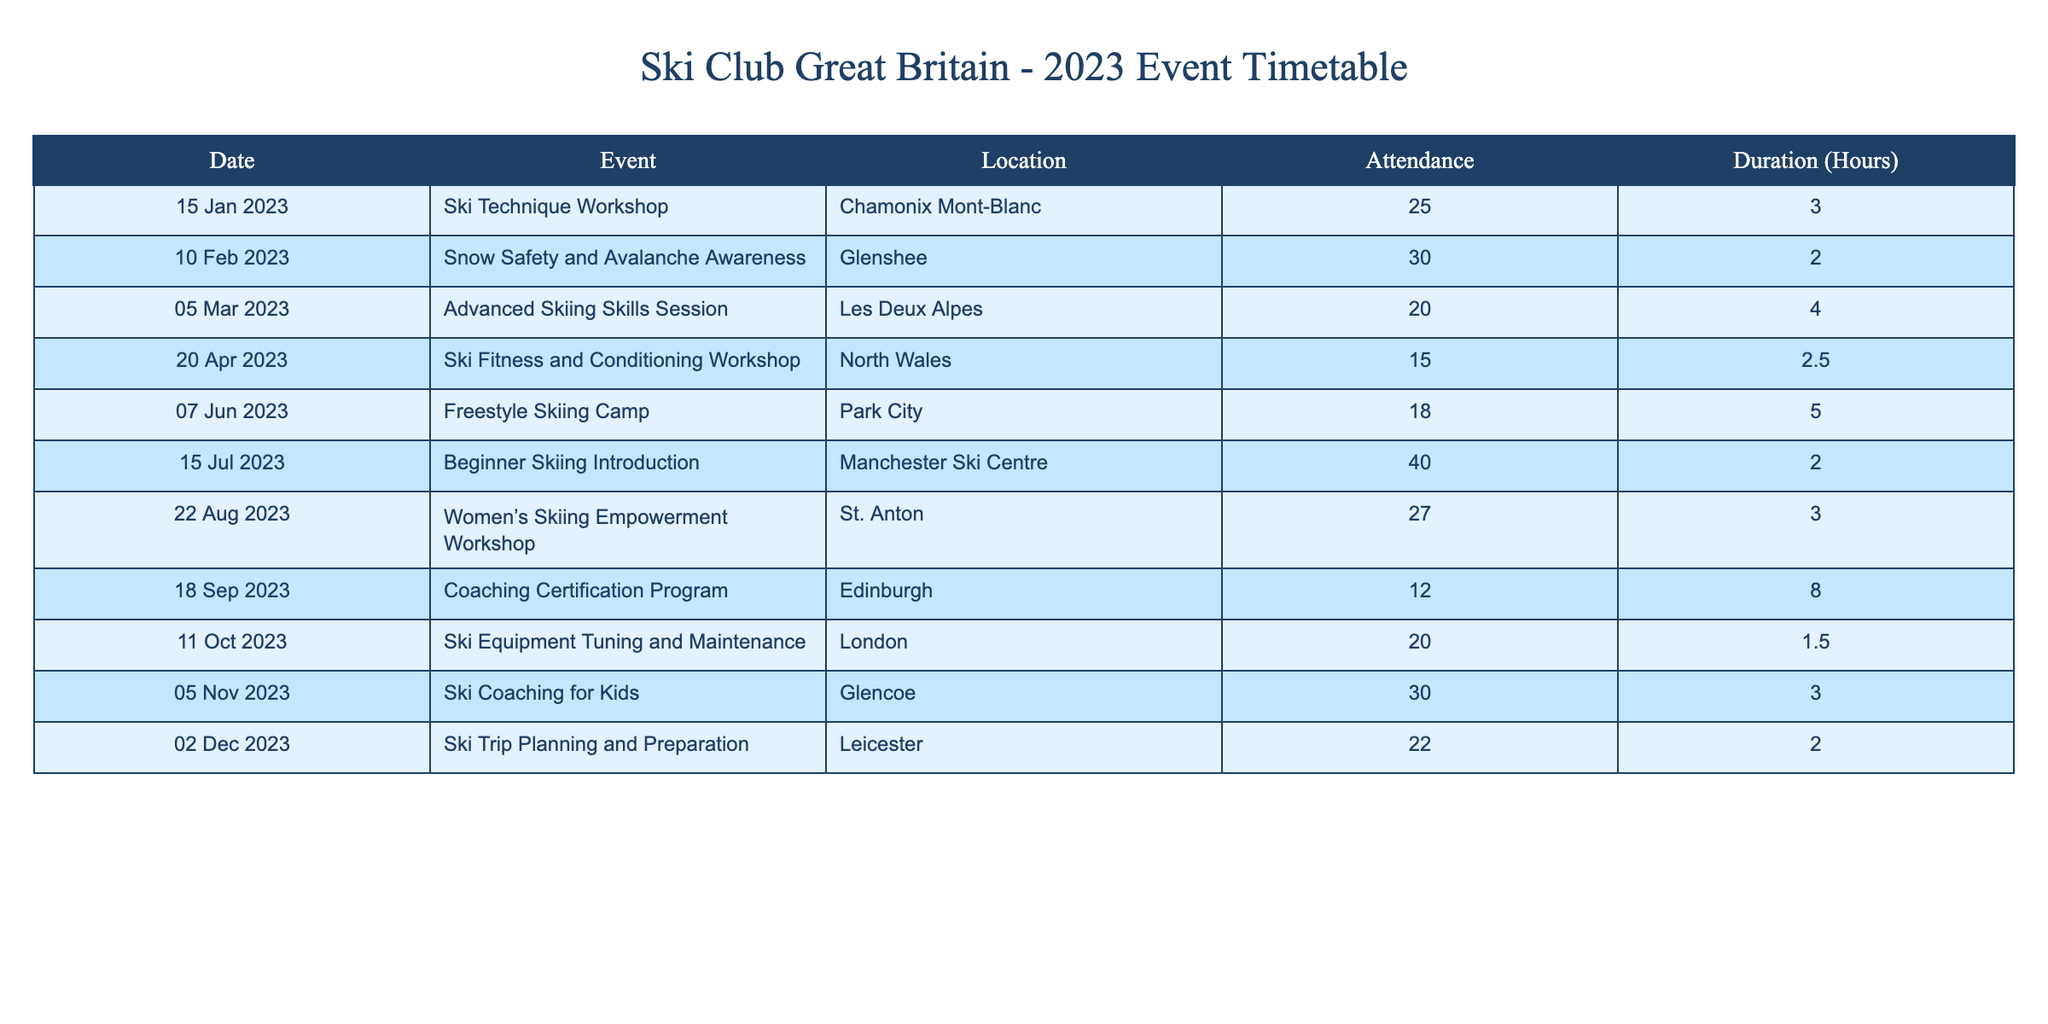What is the highest attendance recorded for a workshop in 2023? The attendance numbers from the table show that the "Beginner Skiing Introduction" event held on July 15 had the highest attendance with 40 participants.
Answer: 40 Which event had the longest duration in hours? By reviewing the duration column, the "Coaching Certification Program" held on September 18 had the longest duration of 8 hours.
Answer: 8 hours What was the average attendance for Ski Club Great Britain events in 2023? To find the average attendance, sum all attendance figures: (25 + 30 + 20 + 15 + 18 + 40 + 27 + 12 + 20 + 30 + 22) =  309. In total, there are 11 events, so the average is 309/11 = 28.09, rounding down gives approximately 28.
Answer: 28 Did more people attend the workshops in Chamonix Mont-Blanc or North Wales? In Chamonix Mont-Blanc, the "Ski Technique Workshop" had 25 attendees, while the workshop in North Wales had 15 attendees for the "Ski Fitness and Conditioning Workshop." Since 25 is greater than 15, more people attended the workshop in Chamonix Mont-Blanc.
Answer: Yes Which month had the lowest attendance for ski training sessions and workshops? Reviewing the attendance figures by month, April had the lowest attendance with "Ski Fitness and Conditioning Workshop" having 15 participants. This is lower than any other month's attendance.
Answer: April How many workshops had an attendance greater than 25 people? The events with attendance above 25 are: "Snow Safety and Avalanche Awareness" (30), "Beginner Skiing Introduction" (40), "Women’s Skiing Empowerment Workshop" (27), and "Ski Coaching for Kids" (30). That totals 4 workshops.
Answer: 4 What is the difference in attendance between the "Freestyle Skiing Camp" and the "Advanced Skiing Skills Session"? The "Freestyle Skiing Camp" had 18 attendees and the "Advanced Skiing Skills Session" had 20 attendees. The difference in attendance is calculated as 20 - 18 = 2 attendees.
Answer: 2 Which location hosted the event with the lowest attendance overall? The event with the lowest attendance was the "Coaching Certification Program" in Edinburgh, which had only 12 participants. This is the lowest attendance recorded.
Answer: Edinburgh How many events were held in the summer months (June to August)? The summer months included June, July, and August. Events held in these months are: "Freestyle Skiing Camp" (June), "Beginner Skiing Introduction" (July), and "Women’s Skiing Empowerment Workshop" (August), totaling 3 events.
Answer: 3 